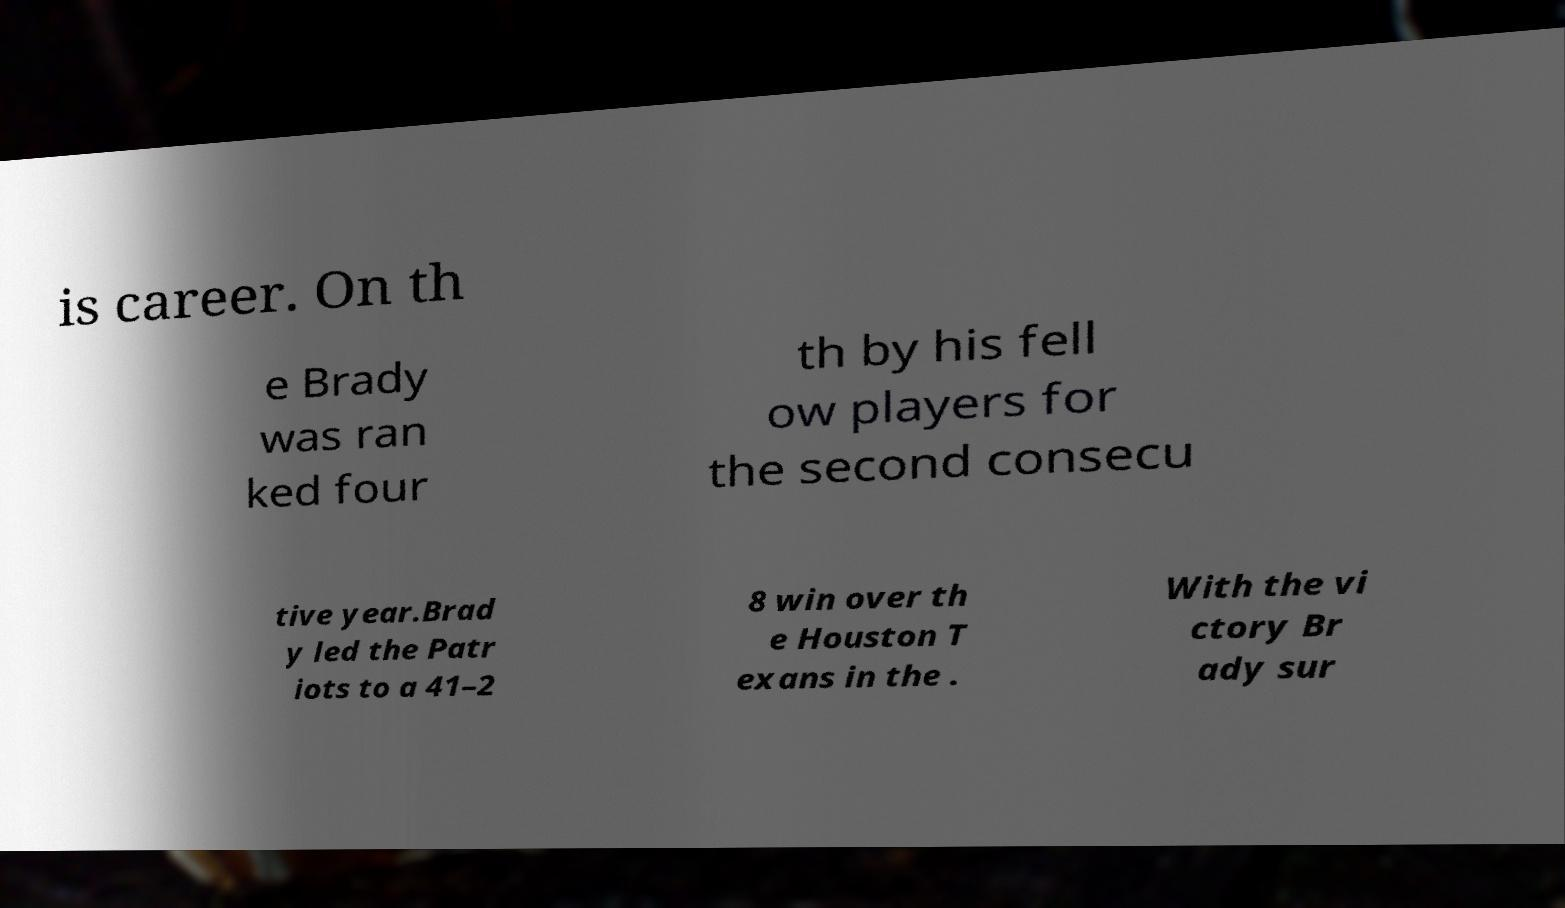Can you read and provide the text displayed in the image?This photo seems to have some interesting text. Can you extract and type it out for me? is career. On th e Brady was ran ked four th by his fell ow players for the second consecu tive year.Brad y led the Patr iots to a 41–2 8 win over th e Houston T exans in the . With the vi ctory Br ady sur 